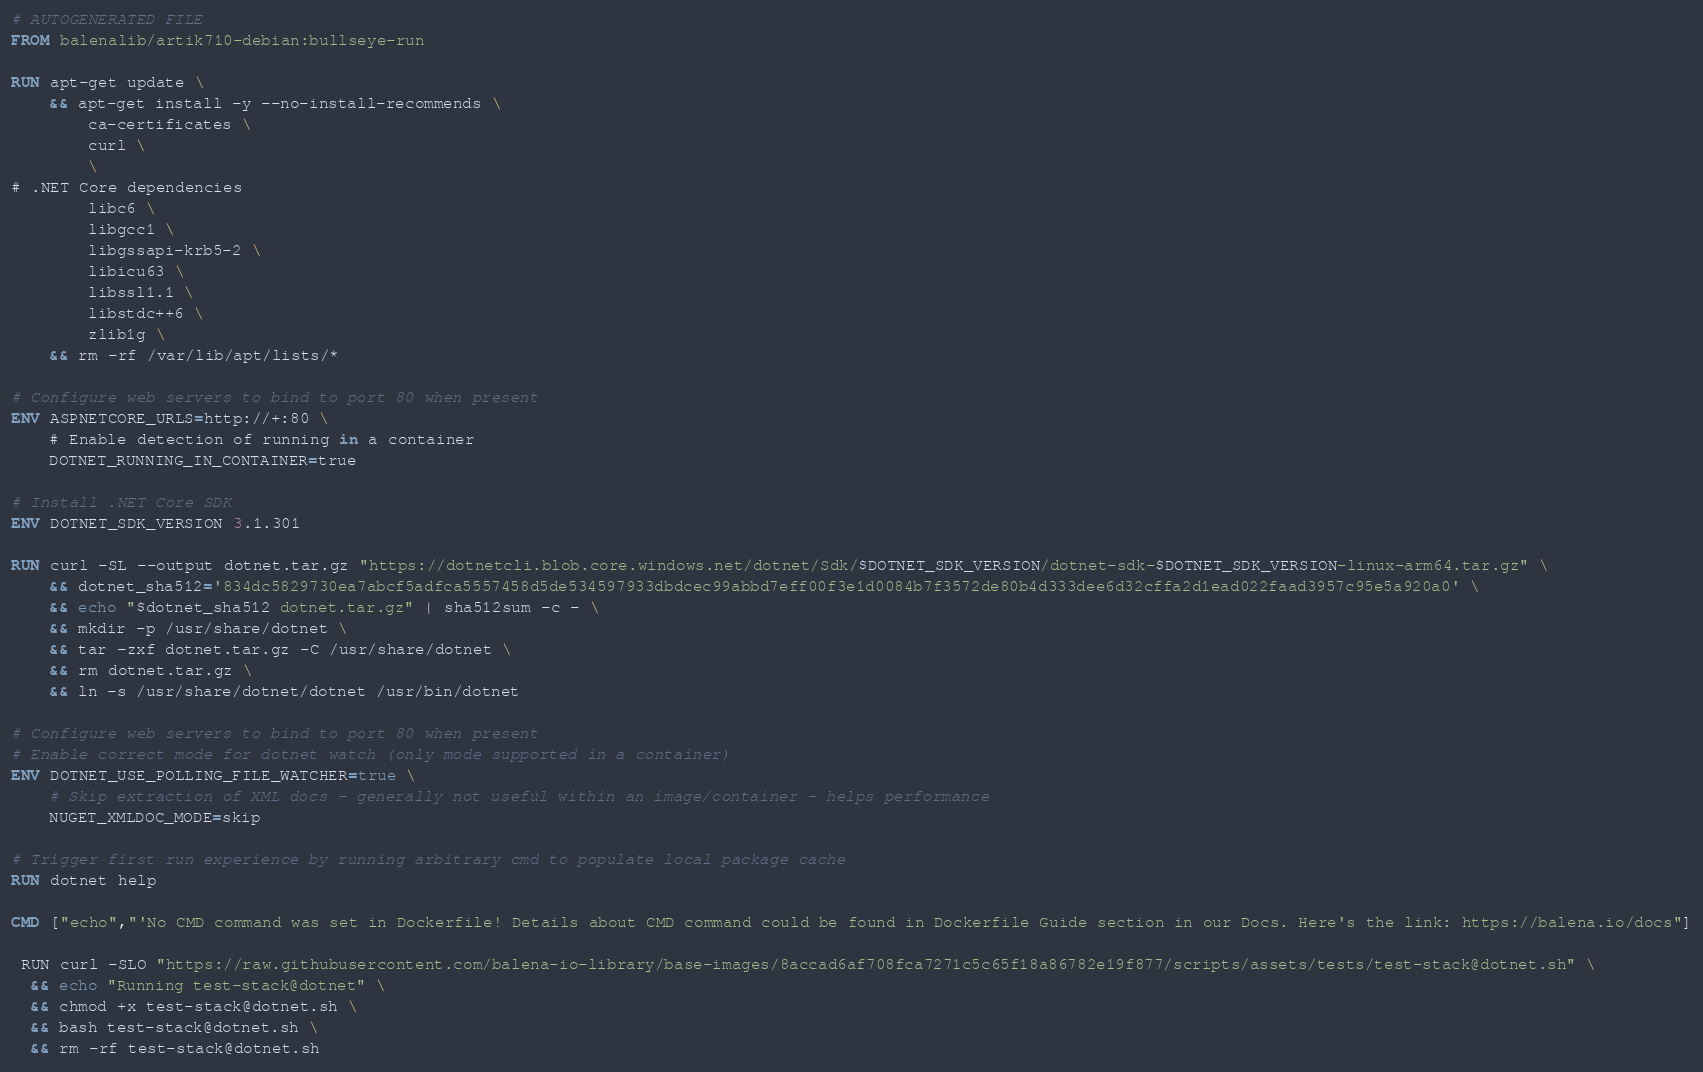<code> <loc_0><loc_0><loc_500><loc_500><_Dockerfile_># AUTOGENERATED FILE
FROM balenalib/artik710-debian:bullseye-run

RUN apt-get update \
    && apt-get install -y --no-install-recommends \
        ca-certificates \
        curl \
        \
# .NET Core dependencies
        libc6 \
        libgcc1 \
        libgssapi-krb5-2 \
        libicu63 \
        libssl1.1 \
        libstdc++6 \
        zlib1g \
    && rm -rf /var/lib/apt/lists/*

# Configure web servers to bind to port 80 when present
ENV ASPNETCORE_URLS=http://+:80 \
    # Enable detection of running in a container
    DOTNET_RUNNING_IN_CONTAINER=true

# Install .NET Core SDK
ENV DOTNET_SDK_VERSION 3.1.301

RUN curl -SL --output dotnet.tar.gz "https://dotnetcli.blob.core.windows.net/dotnet/Sdk/$DOTNET_SDK_VERSION/dotnet-sdk-$DOTNET_SDK_VERSION-linux-arm64.tar.gz" \
    && dotnet_sha512='834dc5829730ea7abcf5adfca5557458d5de534597933dbdcec99abbd7eff00f3e1d0084b7f3572de80b4d333dee6d32cffa2d1ead022faad3957c95e5a920a0' \
    && echo "$dotnet_sha512 dotnet.tar.gz" | sha512sum -c - \
    && mkdir -p /usr/share/dotnet \
    && tar -zxf dotnet.tar.gz -C /usr/share/dotnet \
    && rm dotnet.tar.gz \
    && ln -s /usr/share/dotnet/dotnet /usr/bin/dotnet

# Configure web servers to bind to port 80 when present
# Enable correct mode for dotnet watch (only mode supported in a container)
ENV DOTNET_USE_POLLING_FILE_WATCHER=true \
    # Skip extraction of XML docs - generally not useful within an image/container - helps performance
    NUGET_XMLDOC_MODE=skip

# Trigger first run experience by running arbitrary cmd to populate local package cache
RUN dotnet help

CMD ["echo","'No CMD command was set in Dockerfile! Details about CMD command could be found in Dockerfile Guide section in our Docs. Here's the link: https://balena.io/docs"]

 RUN curl -SLO "https://raw.githubusercontent.com/balena-io-library/base-images/8accad6af708fca7271c5c65f18a86782e19f877/scripts/assets/tests/test-stack@dotnet.sh" \
  && echo "Running test-stack@dotnet" \
  && chmod +x test-stack@dotnet.sh \
  && bash test-stack@dotnet.sh \
  && rm -rf test-stack@dotnet.sh 
</code> 